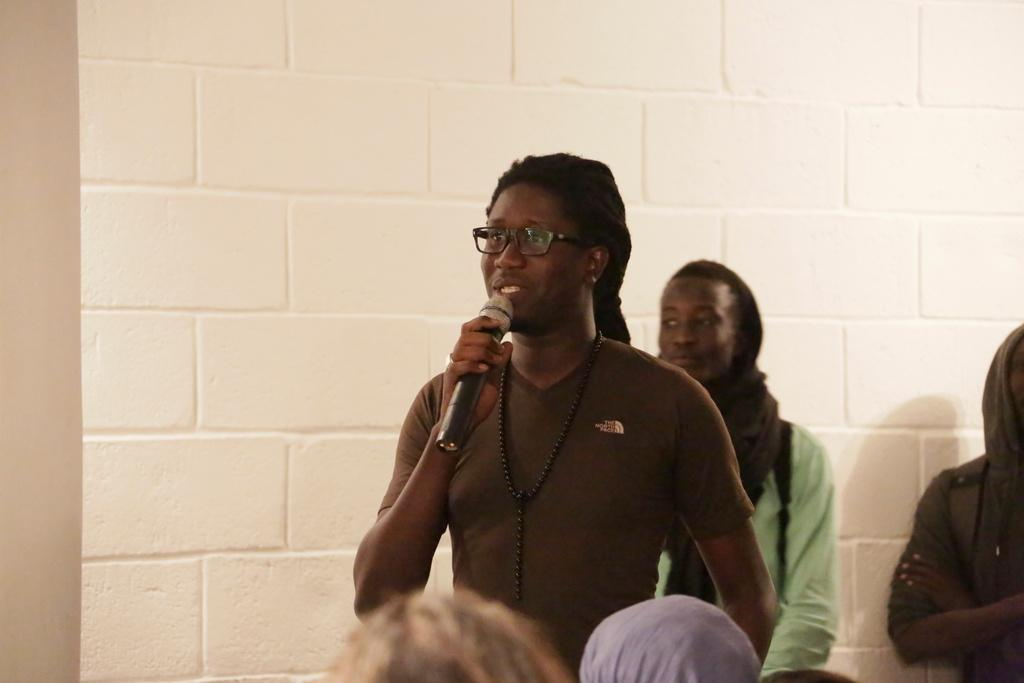What is the person in the image holding? The person is holding a mic in the image. Can you describe the person's appearance? The person is wearing spectacles. Are there any other people visible in the image? Yes, there are people visible in the image. What can be seen in the background of the image? There is a wall in the background of the image. What type of garden can be seen in the image? There is no garden present in the image. How does the person plan to increase the audience's engagement during the event? The image does not provide information about the person's plans or the event, so we cannot answer this question. 